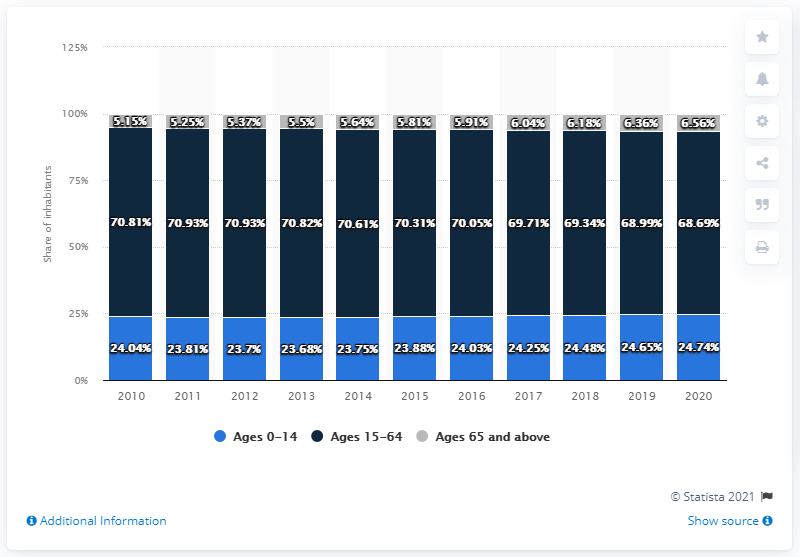Identify some key points in this picture. In 2011 or 2012, the year with the highest age structure of individuals between 15 and 64 years old was [2011, 2012]. We would like to find the sum of the highest number and smallest age in a structure that includes all ages between 0-14 years old. 